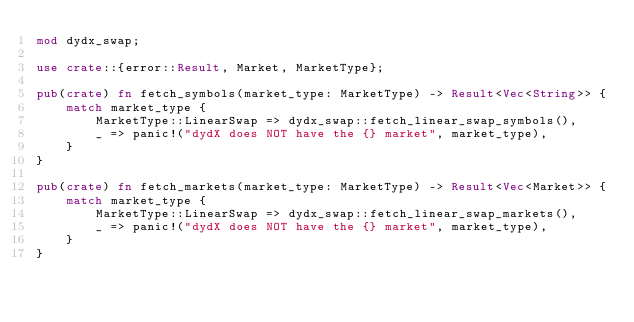<code> <loc_0><loc_0><loc_500><loc_500><_Rust_>mod dydx_swap;

use crate::{error::Result, Market, MarketType};

pub(crate) fn fetch_symbols(market_type: MarketType) -> Result<Vec<String>> {
    match market_type {
        MarketType::LinearSwap => dydx_swap::fetch_linear_swap_symbols(),
        _ => panic!("dydX does NOT have the {} market", market_type),
    }
}

pub(crate) fn fetch_markets(market_type: MarketType) -> Result<Vec<Market>> {
    match market_type {
        MarketType::LinearSwap => dydx_swap::fetch_linear_swap_markets(),
        _ => panic!("dydX does NOT have the {} market", market_type),
    }
}
</code> 